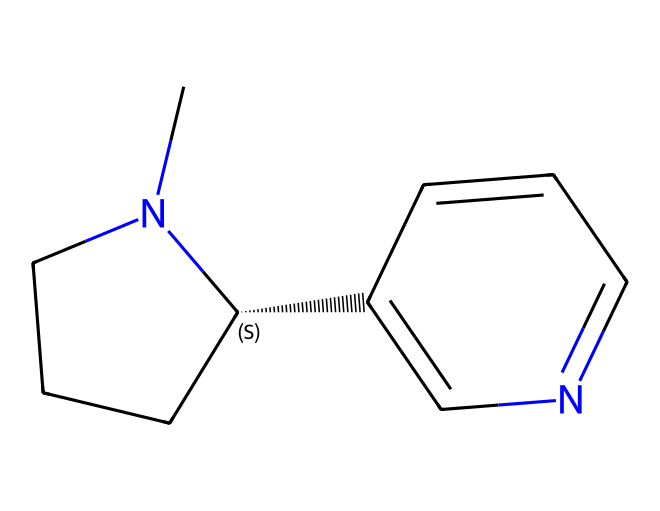What is the main nitrogen-containing group in this chemical? The chemical structure depicts a bicyclic compound that includes a nitrogen atom integrated into its ring system. This nitrogen-containing group contributes to the classification of nicotine as a pyridine and pyrrolidine alkaloid.
Answer: pyridine How many carbon atoms are present in this compound? By examining the SMILES representation and counting each carbon atom indicated, we find that there are a total of 10 carbon atoms in the structure.
Answer: 10 What type of drug is this compound classified as? The structure is identified as nicotine, which is an alkaloid derived from tobacco, commonly recognized for its stimulant properties. The presence of nitrogen atoms confirms this classification.
Answer: stimulant Which part of the structure is responsible for its psychoactive effects? The bicyclic nature of nicotine, specifically the presence of the nitrogen atom in the pyridine ring, is crucial for its interaction with nicotinic acetylcholine receptors in the brain, leading to its psychoactive effects.
Answer: nitrogen What rings are present in the chemical structure of this compound? Upon examining the structure, it consists of two fused rings known as a bicyclic framework: one is a pyridine ring and the other is a pyrrolidine ring.
Answer: bicyclic What is the overall molecular formula based on the structure? By analyzing the structure composed of 10 carbons, 14 hydrogens, and 2 nitrogens, the molecular formula can be derived to be C10H14N2.
Answer: C10H14N2 